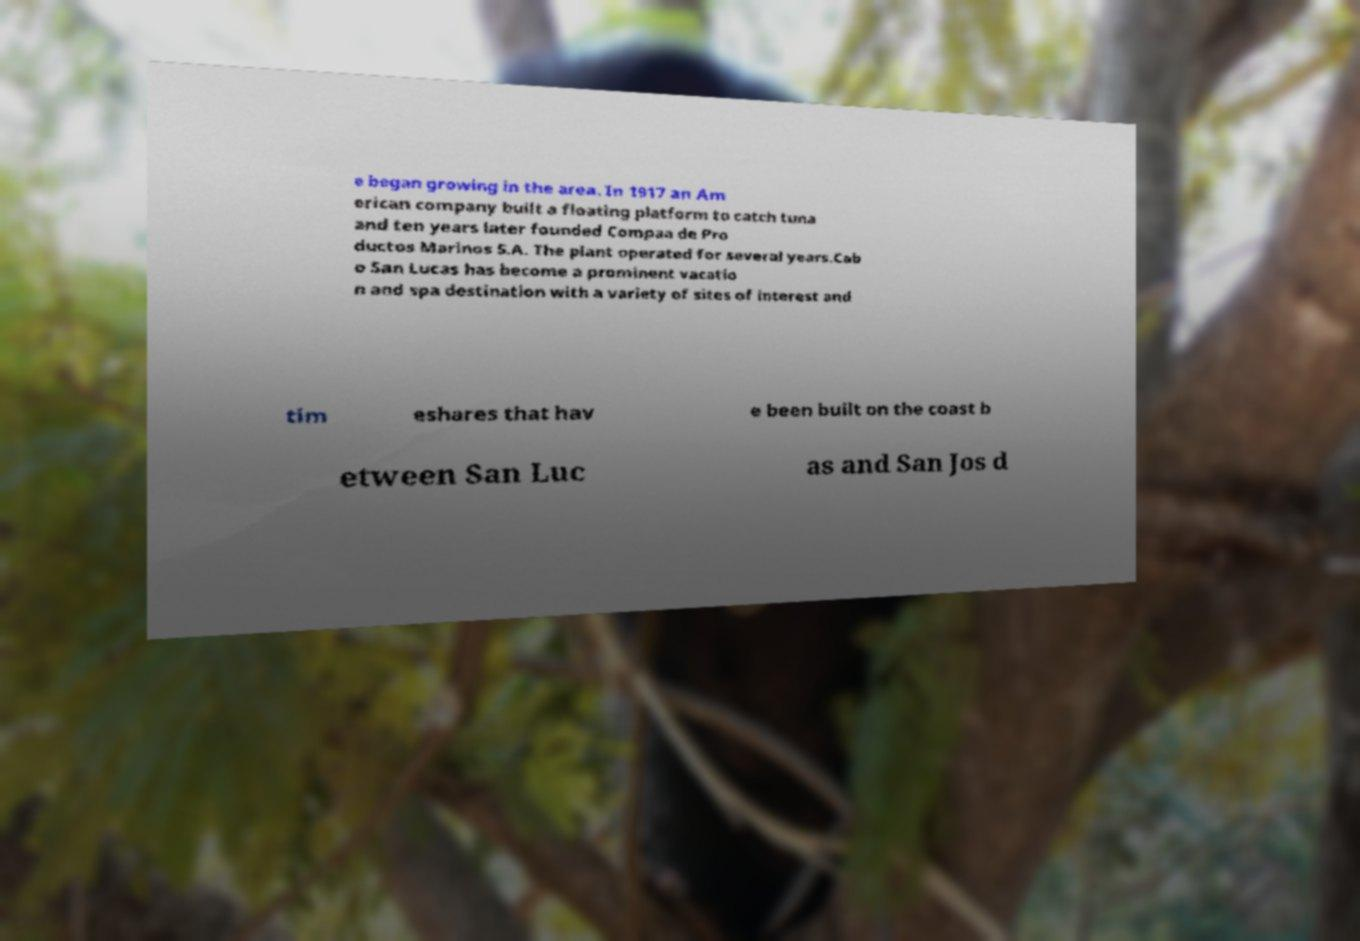I need the written content from this picture converted into text. Can you do that? e began growing in the area. In 1917 an Am erican company built a floating platform to catch tuna and ten years later founded Compaa de Pro ductos Marinos S.A. The plant operated for several years.Cab o San Lucas has become a prominent vacatio n and spa destination with a variety of sites of interest and tim eshares that hav e been built on the coast b etween San Luc as and San Jos d 